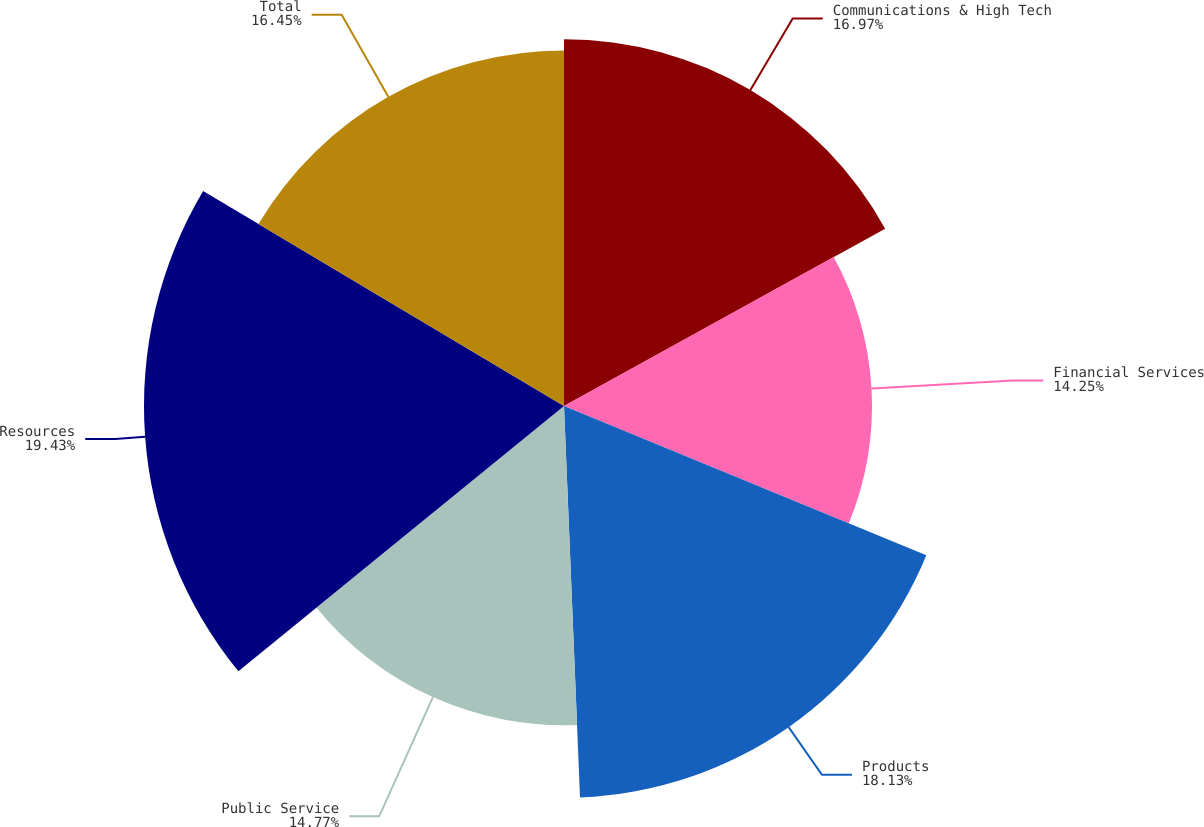Convert chart. <chart><loc_0><loc_0><loc_500><loc_500><pie_chart><fcel>Communications & High Tech<fcel>Financial Services<fcel>Products<fcel>Public Service<fcel>Resources<fcel>Total<nl><fcel>16.97%<fcel>14.25%<fcel>18.13%<fcel>14.77%<fcel>19.43%<fcel>16.45%<nl></chart> 